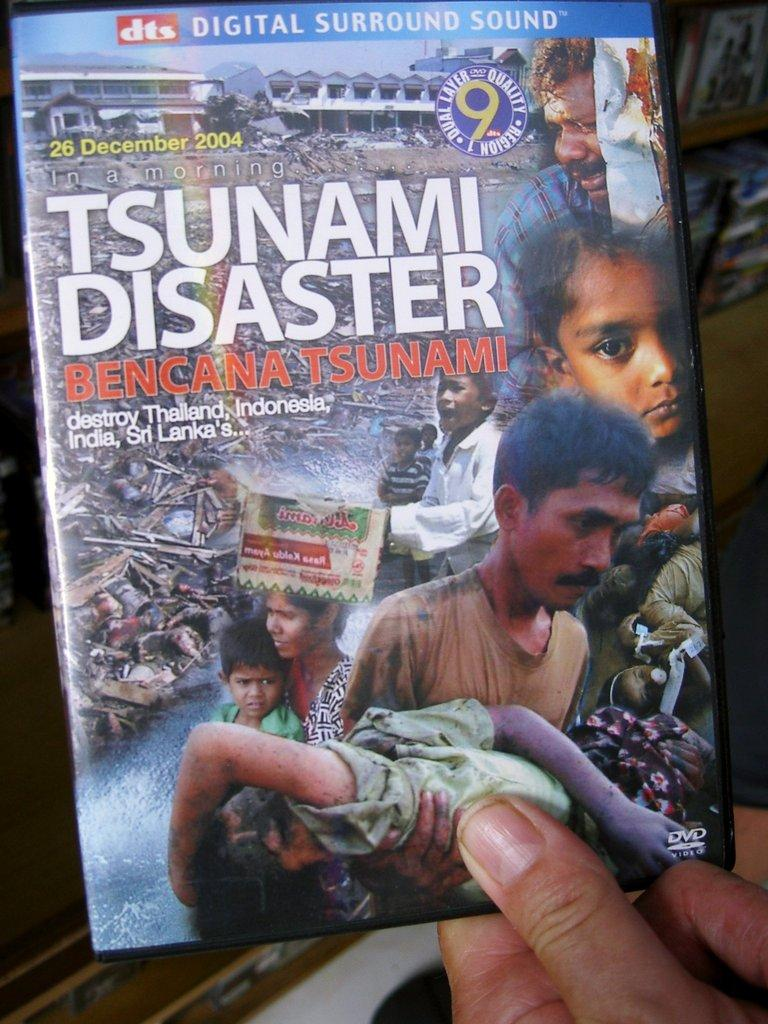What can be seen in the image? There is a person's hand in the image. What is the hand holding? The hand is holding a compact disc. What type of letter is the person wearing on their head in the image? There is no letter or hat present in the image; it only shows a person's hand holding a compact disc. 